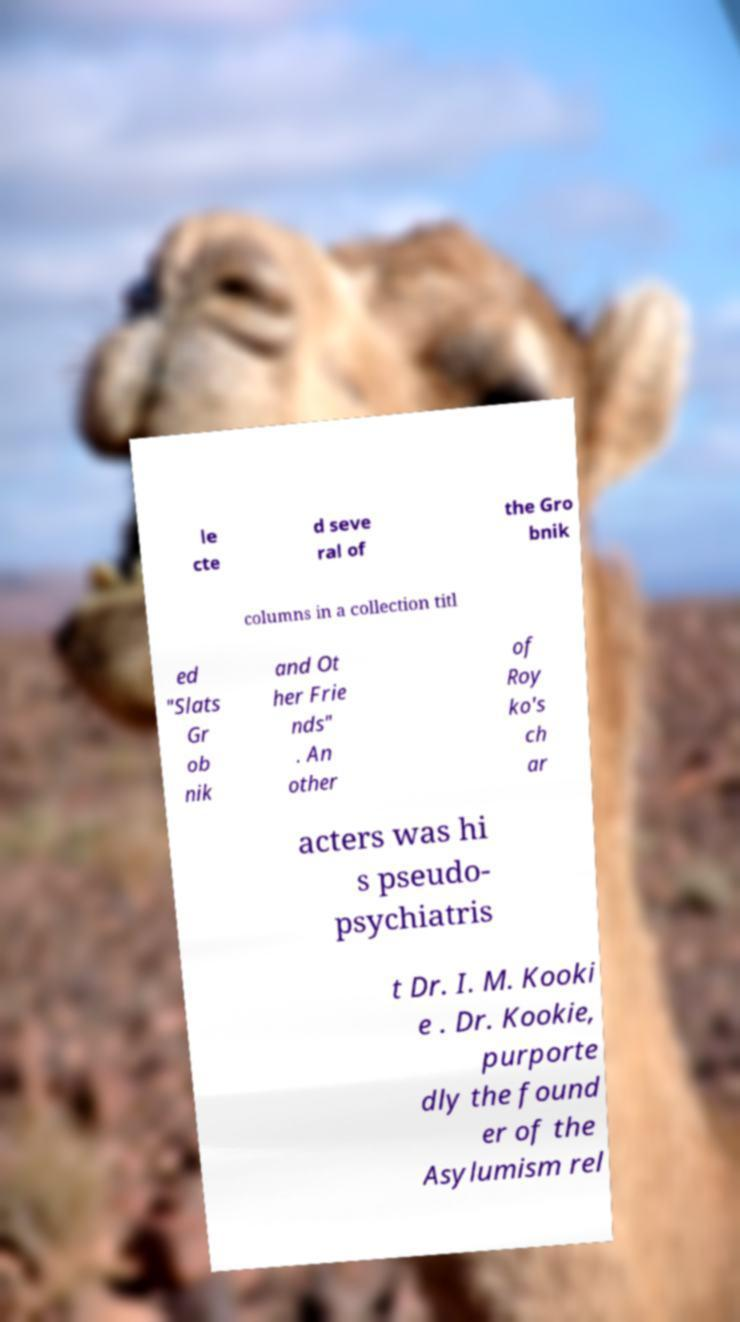Could you extract and type out the text from this image? le cte d seve ral of the Gro bnik columns in a collection titl ed "Slats Gr ob nik and Ot her Frie nds" . An other of Roy ko's ch ar acters was hi s pseudo- psychiatris t Dr. I. M. Kooki e . Dr. Kookie, purporte dly the found er of the Asylumism rel 